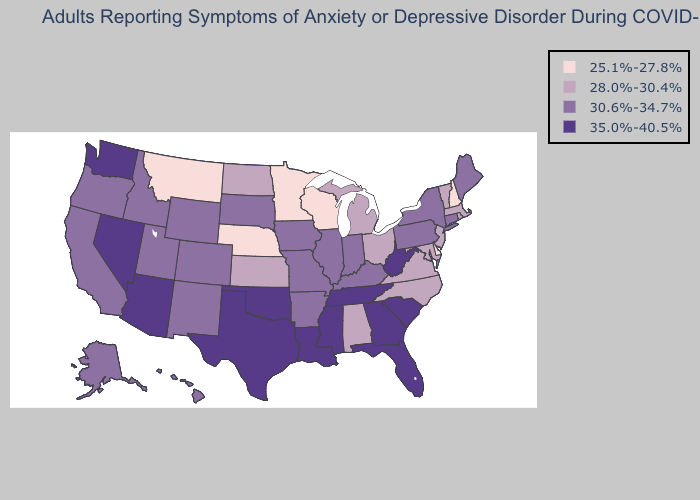Does Indiana have a lower value than North Carolina?
Answer briefly. No. Does the map have missing data?
Keep it brief. No. Among the states that border Iowa , which have the lowest value?
Keep it brief. Minnesota, Nebraska, Wisconsin. Name the states that have a value in the range 30.6%-34.7%?
Keep it brief. Alaska, Arkansas, California, Colorado, Connecticut, Hawaii, Idaho, Illinois, Indiana, Iowa, Kentucky, Maine, Missouri, New Mexico, New York, Oregon, Pennsylvania, South Dakota, Utah, Wyoming. What is the value of Maine?
Quick response, please. 30.6%-34.7%. Which states have the lowest value in the West?
Be succinct. Montana. Which states have the highest value in the USA?
Short answer required. Arizona, Florida, Georgia, Louisiana, Mississippi, Nevada, Oklahoma, South Carolina, Tennessee, Texas, Washington, West Virginia. Does North Carolina have a higher value than Delaware?
Be succinct. Yes. Does Kansas have the lowest value in the USA?
Give a very brief answer. No. What is the value of North Dakota?
Be succinct. 28.0%-30.4%. Does Michigan have a lower value than New York?
Concise answer only. Yes. Name the states that have a value in the range 30.6%-34.7%?
Keep it brief. Alaska, Arkansas, California, Colorado, Connecticut, Hawaii, Idaho, Illinois, Indiana, Iowa, Kentucky, Maine, Missouri, New Mexico, New York, Oregon, Pennsylvania, South Dakota, Utah, Wyoming. Does the first symbol in the legend represent the smallest category?
Answer briefly. Yes. Does Ohio have a higher value than Iowa?
Give a very brief answer. No. Does Michigan have the highest value in the MidWest?
Quick response, please. No. 